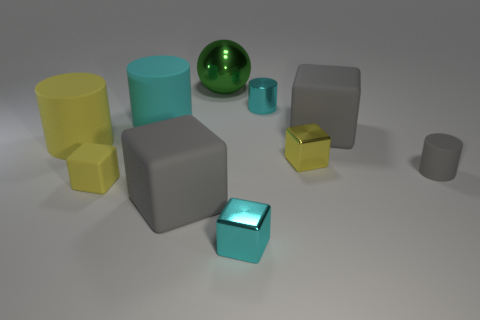What is the material of the small cyan object that is the same shape as the big cyan rubber thing?
Give a very brief answer. Metal. What color is the matte cube that is behind the tiny yellow metal thing?
Your answer should be compact. Gray. Is the number of tiny gray cylinders to the right of the big shiny sphere greater than the number of big gray spheres?
Your response must be concise. Yes. What color is the big metal object?
Your answer should be very brief. Green. What is the shape of the gray matte thing that is to the left of the block that is behind the big yellow rubber object that is to the left of the green object?
Give a very brief answer. Cube. There is a cyan thing that is to the left of the tiny cyan cylinder and behind the big yellow object; what material is it?
Make the answer very short. Rubber. What shape is the tiny thing left of the big green metallic object that is left of the cyan metal cylinder?
Offer a very short reply. Cube. Are there any other things of the same color as the big ball?
Ensure brevity in your answer.  No. Do the yellow rubber block and the cyan shiny object behind the large yellow rubber object have the same size?
Give a very brief answer. Yes. How many tiny things are yellow rubber objects or gray rubber blocks?
Offer a very short reply. 1. 